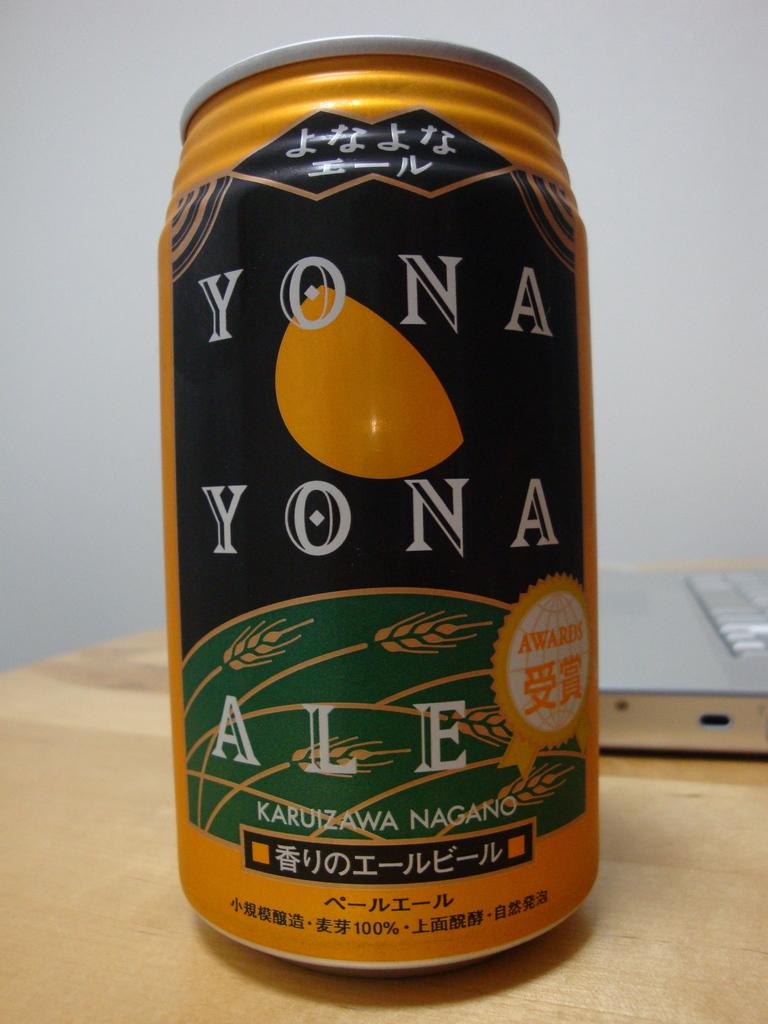<image>
Describe the image concisely. A yellow can contains yona yona ale with a notice of an award. 